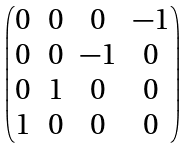Convert formula to latex. <formula><loc_0><loc_0><loc_500><loc_500>\begin{pmatrix} 0 & 0 & 0 & - 1 \\ 0 & 0 & - 1 & 0 \\ 0 & 1 & 0 & 0 \\ 1 & 0 & 0 & 0 \\ \end{pmatrix}</formula> 